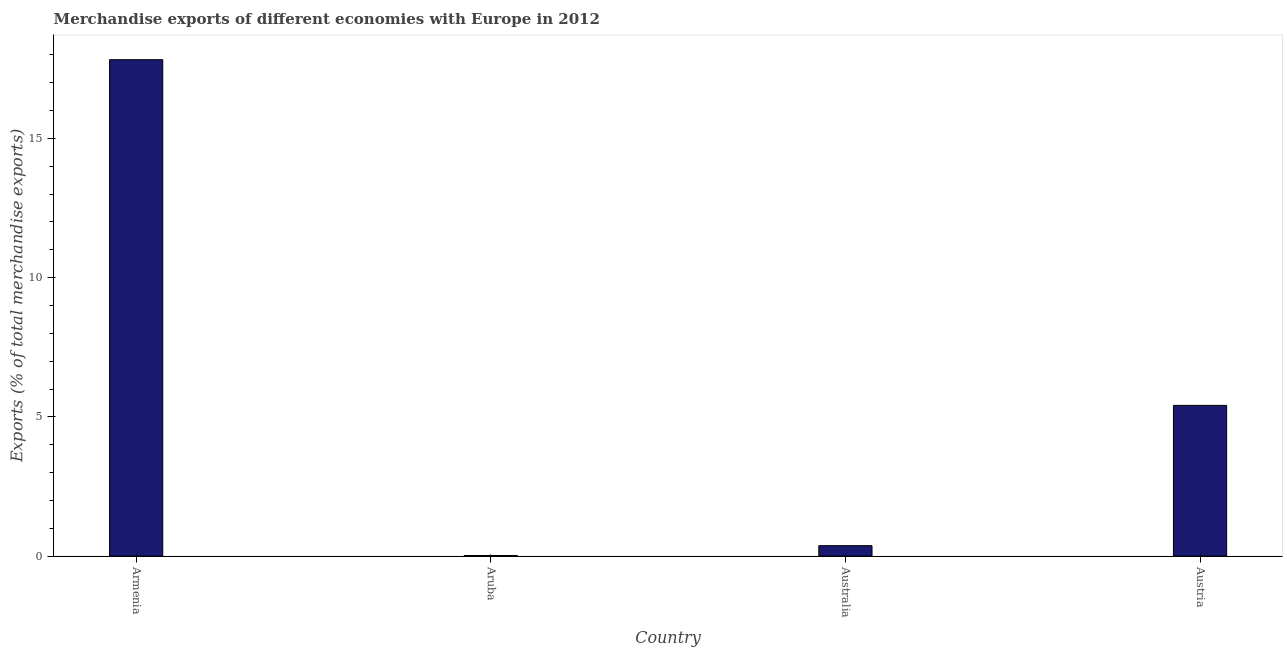Does the graph contain any zero values?
Ensure brevity in your answer.  No. What is the title of the graph?
Offer a terse response. Merchandise exports of different economies with Europe in 2012. What is the label or title of the X-axis?
Give a very brief answer. Country. What is the label or title of the Y-axis?
Your response must be concise. Exports (% of total merchandise exports). What is the merchandise exports in Australia?
Your answer should be compact. 0.38. Across all countries, what is the maximum merchandise exports?
Provide a short and direct response. 17.82. Across all countries, what is the minimum merchandise exports?
Keep it short and to the point. 0.02. In which country was the merchandise exports maximum?
Your answer should be very brief. Armenia. In which country was the merchandise exports minimum?
Keep it short and to the point. Aruba. What is the sum of the merchandise exports?
Provide a short and direct response. 23.64. What is the difference between the merchandise exports in Australia and Austria?
Provide a short and direct response. -5.04. What is the average merchandise exports per country?
Keep it short and to the point. 5.91. What is the median merchandise exports?
Offer a terse response. 2.9. In how many countries, is the merchandise exports greater than 14 %?
Offer a very short reply. 1. What is the ratio of the merchandise exports in Australia to that in Austria?
Keep it short and to the point. 0.07. Is the difference between the merchandise exports in Armenia and Austria greater than the difference between any two countries?
Provide a short and direct response. No. What is the difference between the highest and the second highest merchandise exports?
Provide a short and direct response. 12.41. Is the sum of the merchandise exports in Armenia and Australia greater than the maximum merchandise exports across all countries?
Keep it short and to the point. Yes. What is the difference between the highest and the lowest merchandise exports?
Provide a short and direct response. 17.8. In how many countries, is the merchandise exports greater than the average merchandise exports taken over all countries?
Provide a short and direct response. 1. How many bars are there?
Provide a succinct answer. 4. Are all the bars in the graph horizontal?
Make the answer very short. No. What is the difference between two consecutive major ticks on the Y-axis?
Offer a very short reply. 5. What is the Exports (% of total merchandise exports) of Armenia?
Offer a terse response. 17.82. What is the Exports (% of total merchandise exports) in Aruba?
Offer a very short reply. 0.02. What is the Exports (% of total merchandise exports) in Australia?
Your response must be concise. 0.38. What is the Exports (% of total merchandise exports) of Austria?
Your answer should be very brief. 5.41. What is the difference between the Exports (% of total merchandise exports) in Armenia and Aruba?
Ensure brevity in your answer.  17.8. What is the difference between the Exports (% of total merchandise exports) in Armenia and Australia?
Your response must be concise. 17.45. What is the difference between the Exports (% of total merchandise exports) in Armenia and Austria?
Give a very brief answer. 12.41. What is the difference between the Exports (% of total merchandise exports) in Aruba and Australia?
Provide a succinct answer. -0.35. What is the difference between the Exports (% of total merchandise exports) in Aruba and Austria?
Your response must be concise. -5.39. What is the difference between the Exports (% of total merchandise exports) in Australia and Austria?
Provide a short and direct response. -5.04. What is the ratio of the Exports (% of total merchandise exports) in Armenia to that in Aruba?
Your answer should be very brief. 729.31. What is the ratio of the Exports (% of total merchandise exports) in Armenia to that in Australia?
Ensure brevity in your answer.  47.28. What is the ratio of the Exports (% of total merchandise exports) in Armenia to that in Austria?
Your response must be concise. 3.29. What is the ratio of the Exports (% of total merchandise exports) in Aruba to that in Australia?
Provide a succinct answer. 0.07. What is the ratio of the Exports (% of total merchandise exports) in Aruba to that in Austria?
Keep it short and to the point. 0.01. What is the ratio of the Exports (% of total merchandise exports) in Australia to that in Austria?
Your response must be concise. 0.07. 